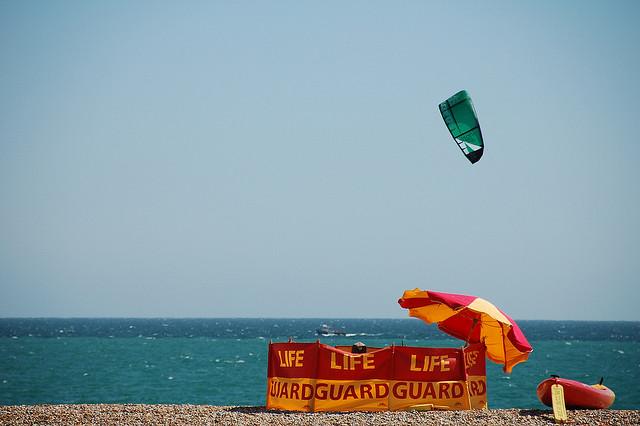Where are the hotels?
Quick response, please. Behind photographer. What does the sign say?
Short answer required. Lifeguard. How high in the air is the kite?
Answer briefly. 20 feet. What profession is likely to use this?
Be succinct. Lifeguard. Is this umbrella open?
Be succinct. Yes. Is there a lifeguard?
Short answer required. Yes. 